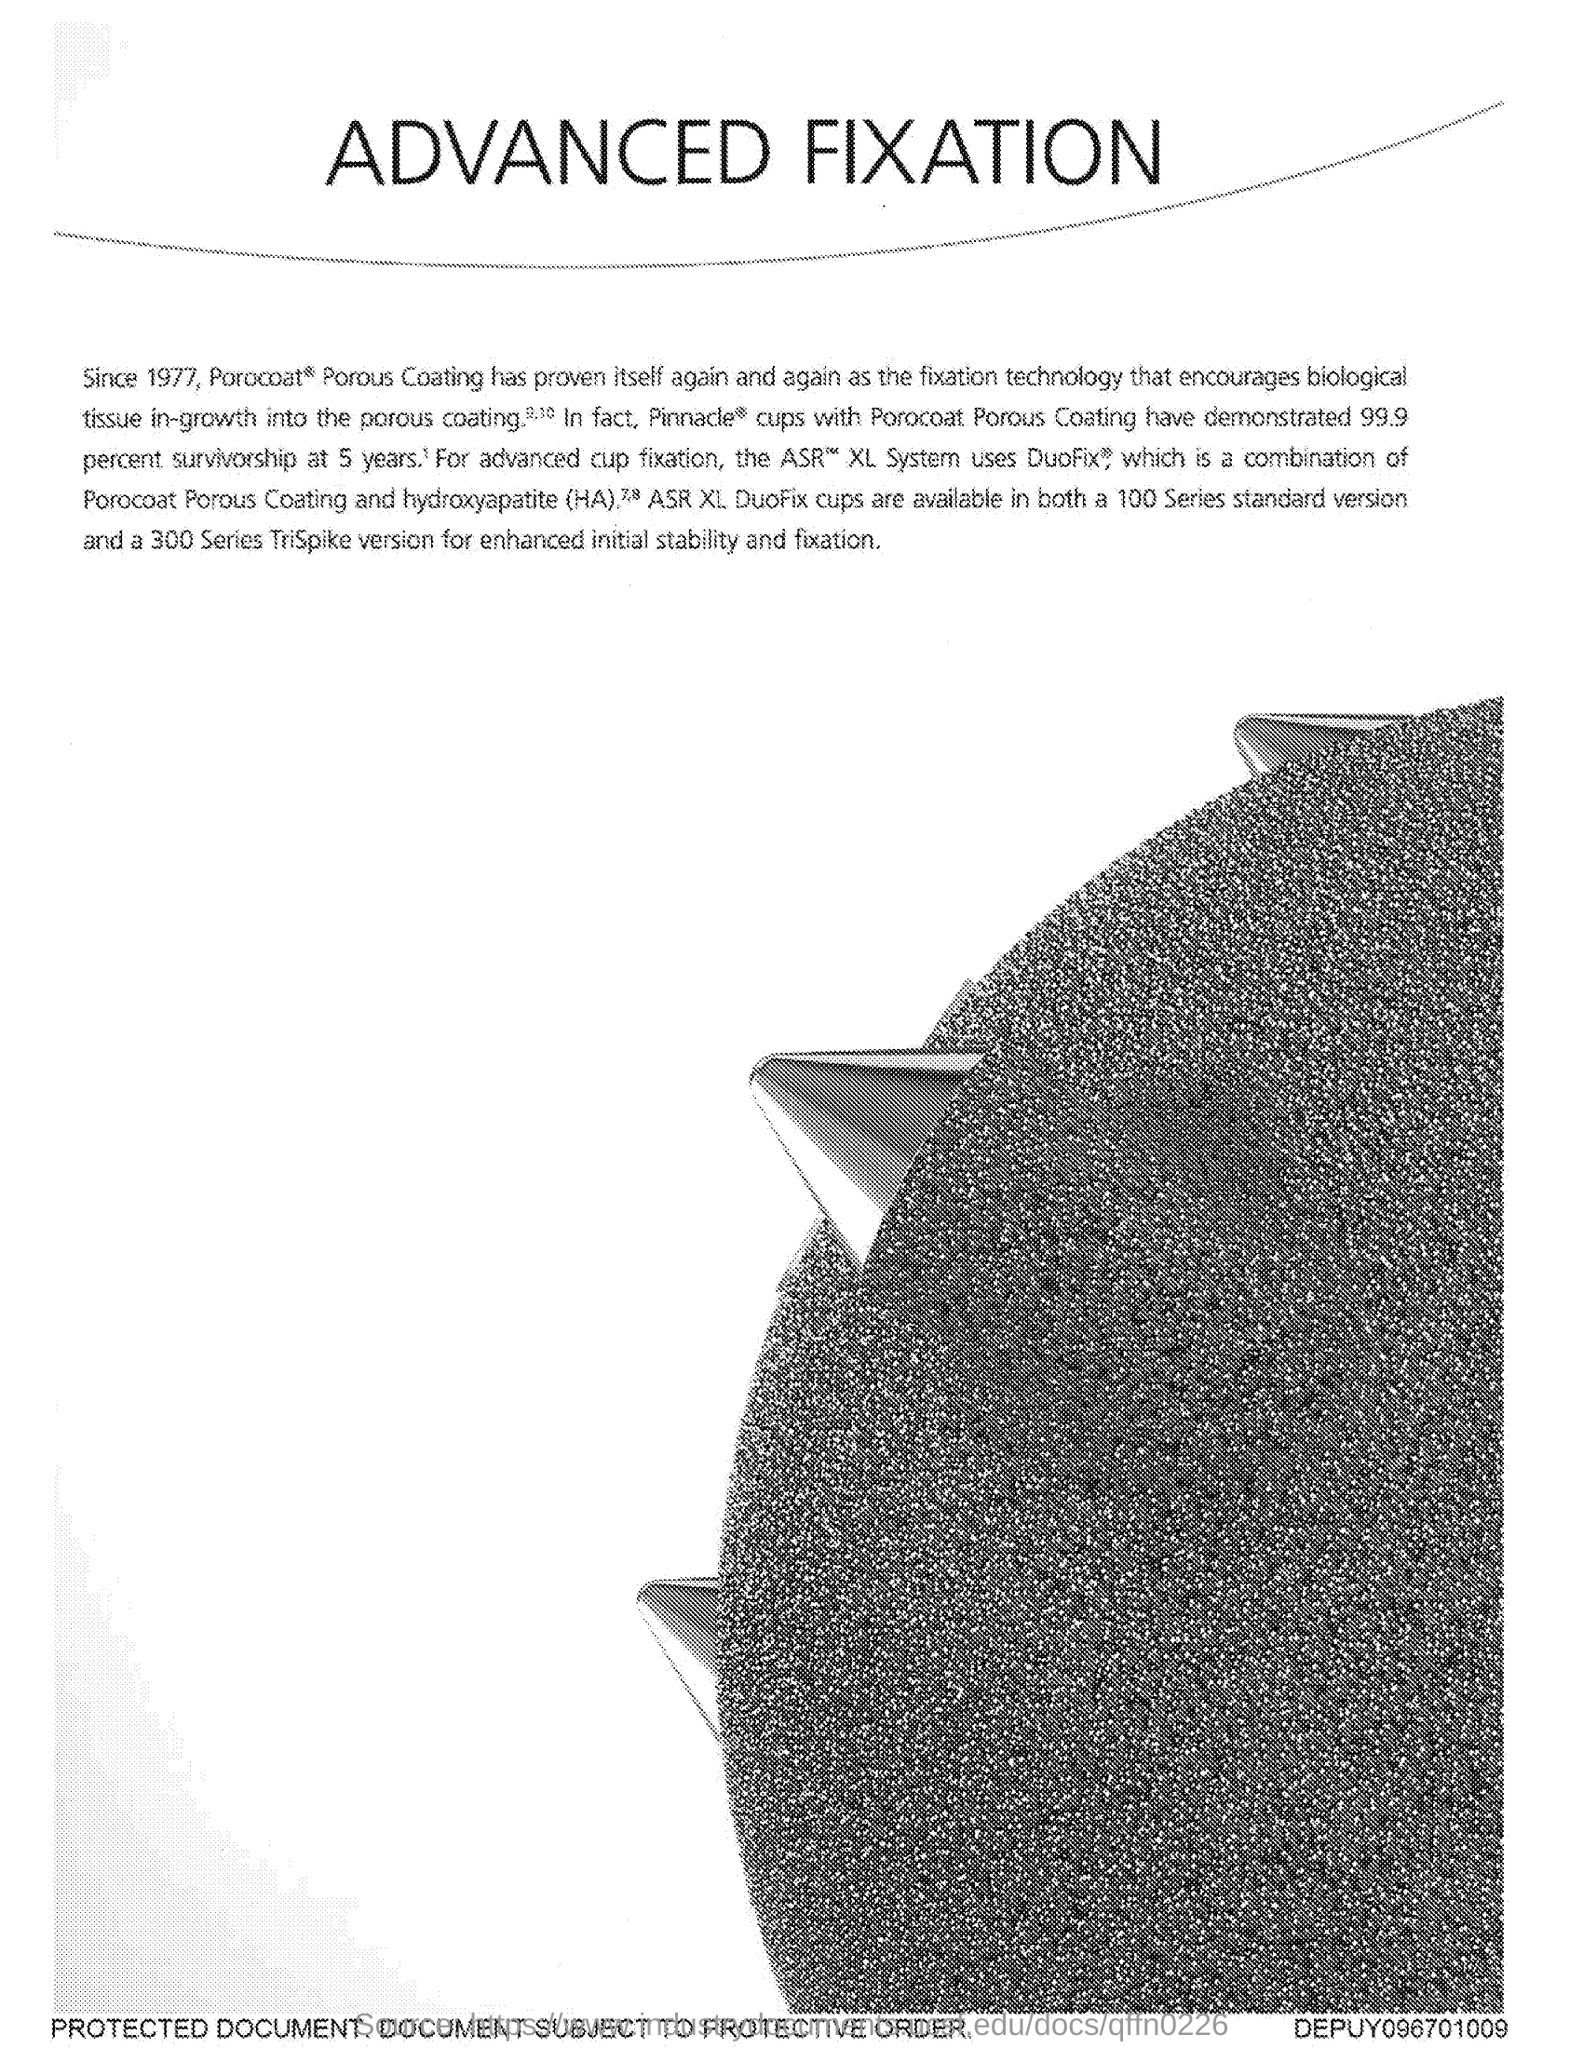Give some essential details in this illustration. The document's title is 'Advanced Fixation'. 